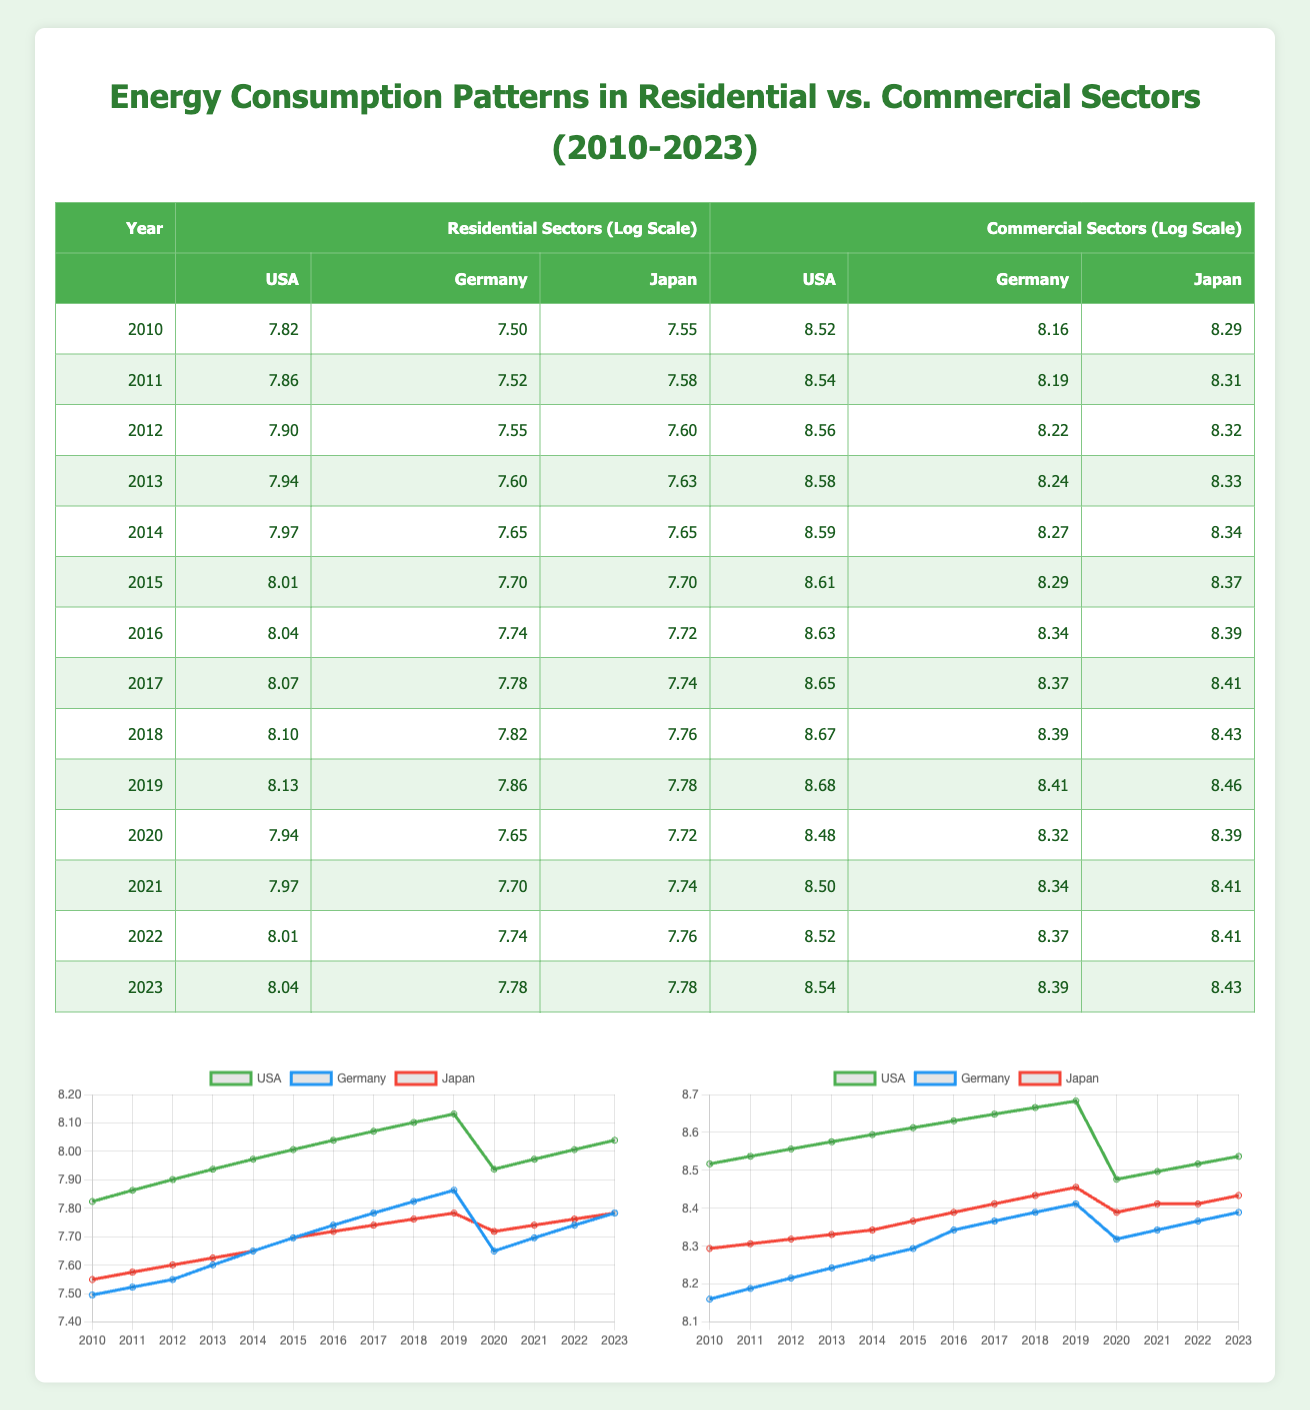What was the residential energy consumption in the USA in 2015? In the table, we locate the year 2015 under the residential sectors for the USA. The value listed is 3000.
Answer: 3000 Which country had the highest residential energy consumption in 2023? In 2023, we compare the residential energy consumption values: USA is 3100, Germany is 2400, and Japan is 2400. The USA has the highest consumption for that year.
Answer: USA What is the difference in commercial energy consumption between the USA and Germany in 2020? In 2020, the USA has a consumption of 4800 and Germany has 4100. The difference is calculated as 4800 - 4100 = 700.
Answer: 700 Is Japan’s residential energy consumption for 2021 greater than the consumption of Germany for the same year? In the table, Japan’s residential energy consumption in 2021 is 2300 and Germany’s is 2200. Since 2300 is greater than 2200, the statement is true.
Answer: Yes What was the average residential energy consumption for Germany during the years 2010-2023? The residential values for Germany are 1800, 1850, 1900, 2000, 2100, 2200, 2300, 2400, 2500, 2600, 2100, 2200, 2300, 2400. Summing these values gives 28350, and there are 14 data points. The average is 28350 / 14 = 2025.
Answer: 2025 In which year did Japan’s commercial energy consumption first exceed 4500? Looking at the table for Japan's commercial energy consumption, the values are 4000, 4050, 4100, 4150, 4200, 4300, 4400, 4500, 4600, 4700, 4400, 4500, 4500, 4600. The first year it exceeds 4500 is 2022.
Answer: 2022 What is the total residential energy consumption for the USA from 2010 to 2013? The residential energy consumption values for the USA from 2010 to 2013 are 2500, 2600, 2700, 2800. Summing these values gives 2500 + 2600 + 2700 + 2800 = 10600.
Answer: 10600 Did residential energy consumption in the USA decrease from 2019 to 2020? In 2019, the residential consumption in the USA was 3400, and in 2020 it decreased to 2800. Since 2800 is less than 3400, the statement is true.
Answer: Yes 